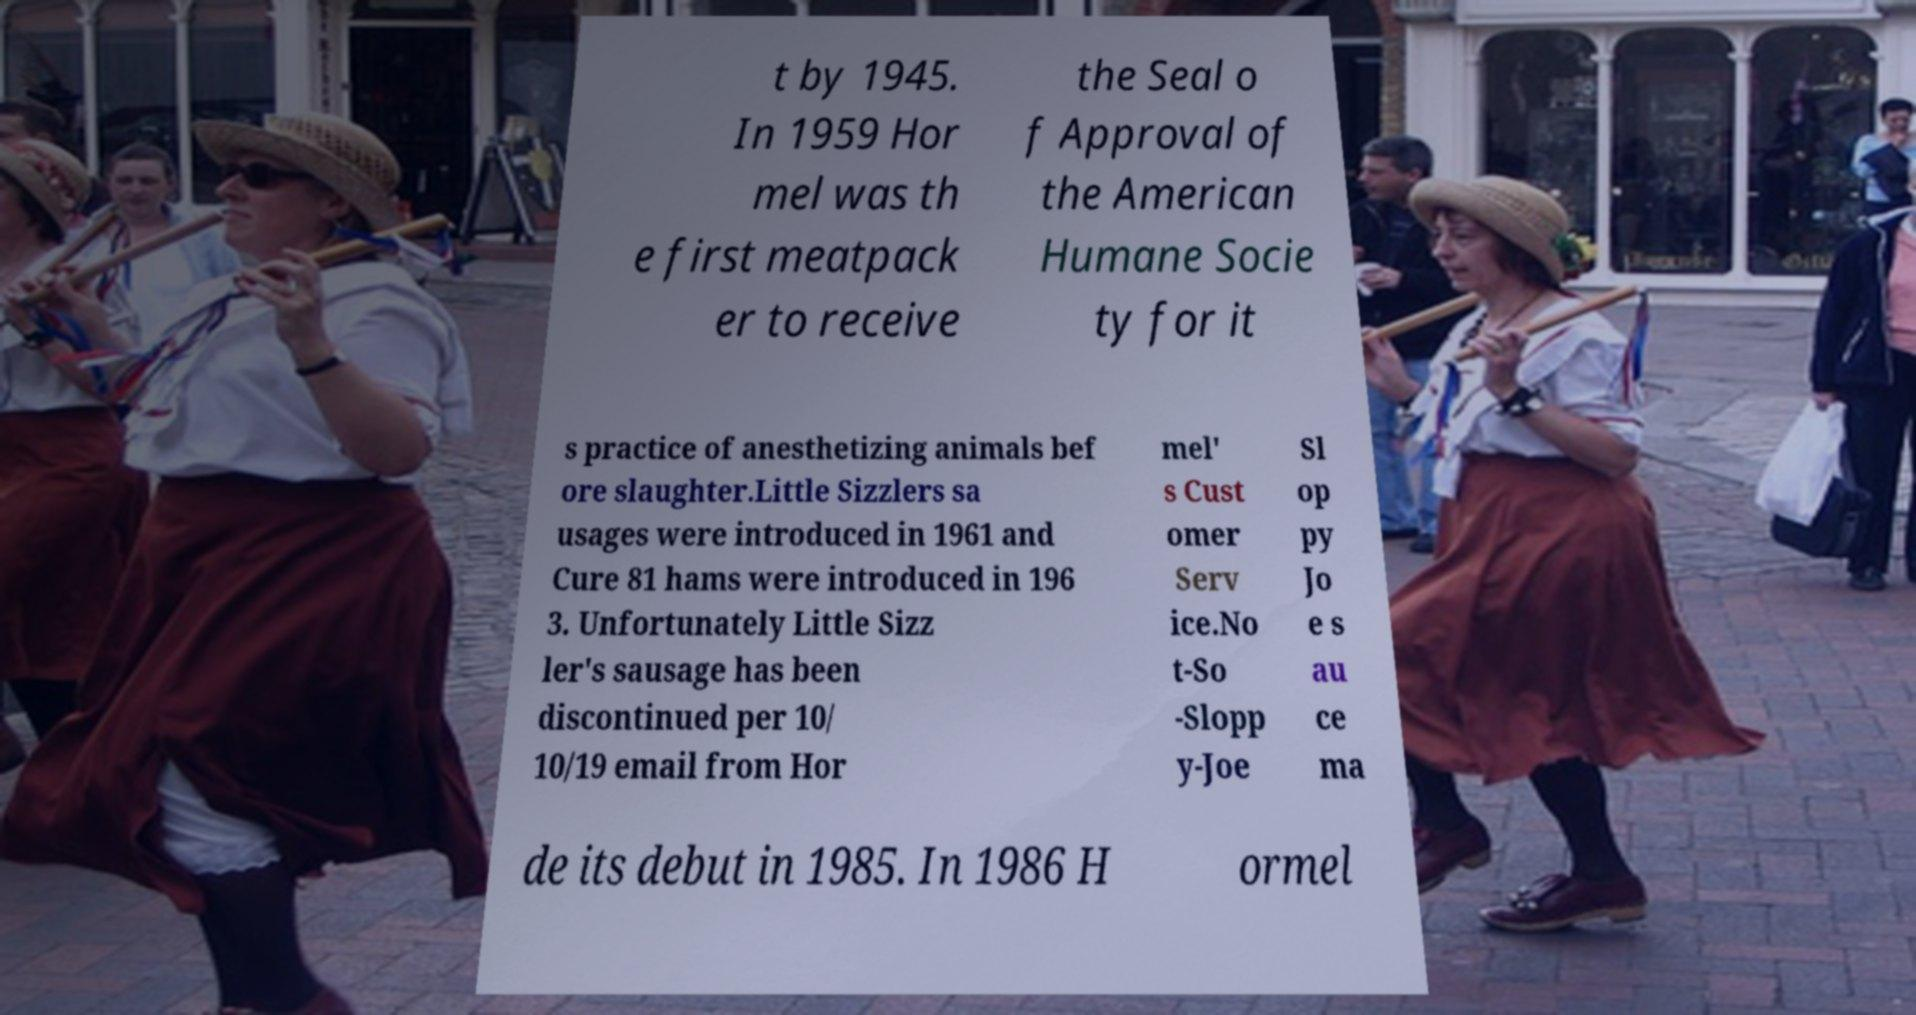There's text embedded in this image that I need extracted. Can you transcribe it verbatim? t by 1945. In 1959 Hor mel was th e first meatpack er to receive the Seal o f Approval of the American Humane Socie ty for it s practice of anesthetizing animals bef ore slaughter.Little Sizzlers sa usages were introduced in 1961 and Cure 81 hams were introduced in 196 3. Unfortunately Little Sizz ler's sausage has been discontinued per 10/ 10/19 email from Hor mel' s Cust omer Serv ice.No t-So -Slopp y-Joe Sl op py Jo e s au ce ma de its debut in 1985. In 1986 H ormel 